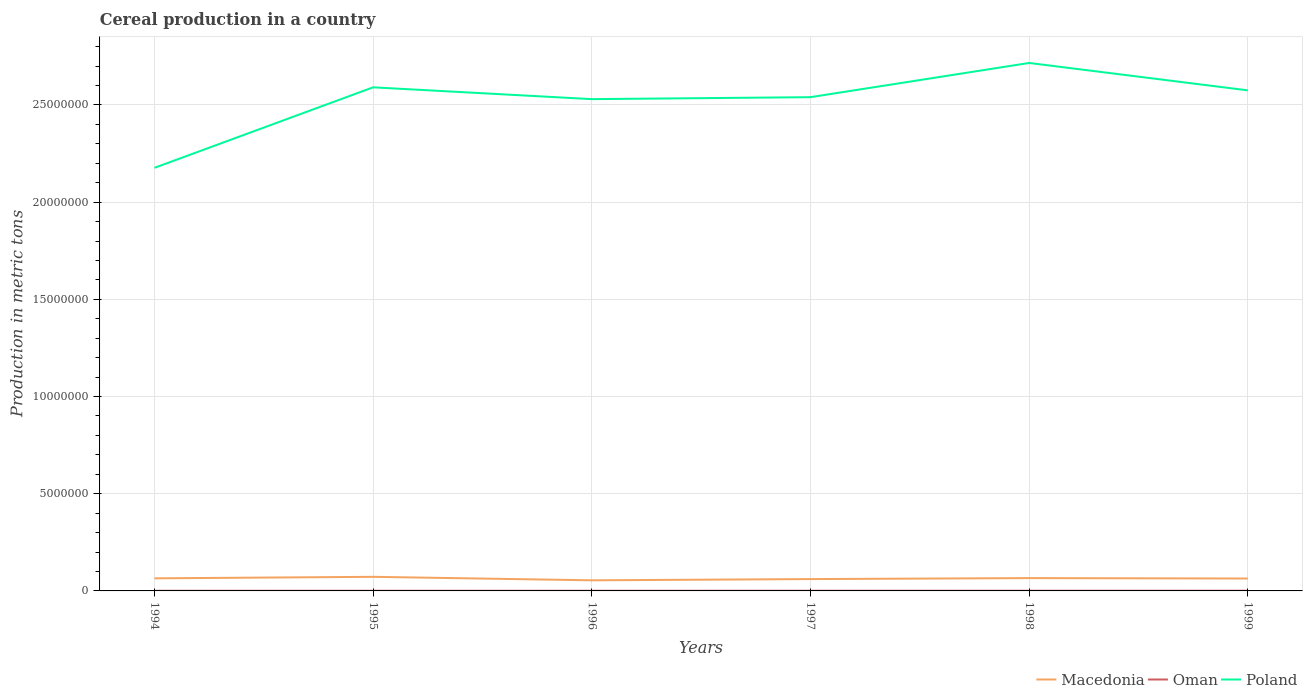How many different coloured lines are there?
Keep it short and to the point. 3. Across all years, what is the maximum total cereal production in Poland?
Make the answer very short. 2.18e+07. In which year was the total cereal production in Oman maximum?
Provide a succinct answer. 1994. What is the total total cereal production in Poland in the graph?
Make the answer very short. -3.99e+06. What is the difference between the highest and the second highest total cereal production in Macedonia?
Provide a short and direct response. 1.79e+05. How many years are there in the graph?
Your response must be concise. 6. Are the values on the major ticks of Y-axis written in scientific E-notation?
Ensure brevity in your answer.  No. Does the graph contain any zero values?
Offer a terse response. No. Does the graph contain grids?
Make the answer very short. Yes. How many legend labels are there?
Provide a short and direct response. 3. What is the title of the graph?
Your answer should be very brief. Cereal production in a country. What is the label or title of the Y-axis?
Your answer should be compact. Production in metric tons. What is the Production in metric tons in Macedonia in 1994?
Your answer should be compact. 6.48e+05. What is the Production in metric tons in Oman in 1994?
Offer a terse response. 7145. What is the Production in metric tons of Poland in 1994?
Provide a succinct answer. 2.18e+07. What is the Production in metric tons of Macedonia in 1995?
Keep it short and to the point. 7.25e+05. What is the Production in metric tons of Oman in 1995?
Your response must be concise. 8000. What is the Production in metric tons of Poland in 1995?
Offer a very short reply. 2.59e+07. What is the Production in metric tons of Macedonia in 1996?
Ensure brevity in your answer.  5.46e+05. What is the Production in metric tons in Oman in 1996?
Ensure brevity in your answer.  8760. What is the Production in metric tons of Poland in 1996?
Your answer should be compact. 2.53e+07. What is the Production in metric tons in Macedonia in 1997?
Ensure brevity in your answer.  6.10e+05. What is the Production in metric tons in Oman in 1997?
Your answer should be compact. 9450. What is the Production in metric tons in Poland in 1997?
Offer a terse response. 2.54e+07. What is the Production in metric tons of Macedonia in 1998?
Provide a short and direct response. 6.60e+05. What is the Production in metric tons of Oman in 1998?
Give a very brief answer. 9697. What is the Production in metric tons of Poland in 1998?
Make the answer very short. 2.72e+07. What is the Production in metric tons of Macedonia in 1999?
Provide a short and direct response. 6.38e+05. What is the Production in metric tons of Oman in 1999?
Offer a terse response. 1.07e+04. What is the Production in metric tons of Poland in 1999?
Keep it short and to the point. 2.58e+07. Across all years, what is the maximum Production in metric tons in Macedonia?
Ensure brevity in your answer.  7.25e+05. Across all years, what is the maximum Production in metric tons in Oman?
Your answer should be very brief. 1.07e+04. Across all years, what is the maximum Production in metric tons in Poland?
Give a very brief answer. 2.72e+07. Across all years, what is the minimum Production in metric tons of Macedonia?
Your response must be concise. 5.46e+05. Across all years, what is the minimum Production in metric tons in Oman?
Offer a terse response. 7145. Across all years, what is the minimum Production in metric tons of Poland?
Provide a succinct answer. 2.18e+07. What is the total Production in metric tons in Macedonia in the graph?
Your answer should be compact. 3.83e+06. What is the total Production in metric tons in Oman in the graph?
Ensure brevity in your answer.  5.37e+04. What is the total Production in metric tons of Poland in the graph?
Offer a terse response. 1.51e+08. What is the difference between the Production in metric tons of Macedonia in 1994 and that in 1995?
Provide a short and direct response. -7.72e+04. What is the difference between the Production in metric tons of Oman in 1994 and that in 1995?
Provide a short and direct response. -855. What is the difference between the Production in metric tons in Poland in 1994 and that in 1995?
Your response must be concise. -4.14e+06. What is the difference between the Production in metric tons of Macedonia in 1994 and that in 1996?
Offer a very short reply. 1.02e+05. What is the difference between the Production in metric tons in Oman in 1994 and that in 1996?
Make the answer very short. -1615. What is the difference between the Production in metric tons in Poland in 1994 and that in 1996?
Provide a short and direct response. -3.53e+06. What is the difference between the Production in metric tons of Macedonia in 1994 and that in 1997?
Keep it short and to the point. 3.81e+04. What is the difference between the Production in metric tons in Oman in 1994 and that in 1997?
Offer a very short reply. -2305. What is the difference between the Production in metric tons in Poland in 1994 and that in 1997?
Offer a terse response. -3.64e+06. What is the difference between the Production in metric tons in Macedonia in 1994 and that in 1998?
Keep it short and to the point. -1.21e+04. What is the difference between the Production in metric tons in Oman in 1994 and that in 1998?
Give a very brief answer. -2552. What is the difference between the Production in metric tons of Poland in 1994 and that in 1998?
Offer a very short reply. -5.40e+06. What is the difference between the Production in metric tons in Macedonia in 1994 and that in 1999?
Keep it short and to the point. 9877. What is the difference between the Production in metric tons of Oman in 1994 and that in 1999?
Your answer should be compact. -3540. What is the difference between the Production in metric tons in Poland in 1994 and that in 1999?
Provide a succinct answer. -3.99e+06. What is the difference between the Production in metric tons of Macedonia in 1995 and that in 1996?
Give a very brief answer. 1.79e+05. What is the difference between the Production in metric tons of Oman in 1995 and that in 1996?
Keep it short and to the point. -760. What is the difference between the Production in metric tons of Poland in 1995 and that in 1996?
Your answer should be compact. 6.07e+05. What is the difference between the Production in metric tons in Macedonia in 1995 and that in 1997?
Provide a short and direct response. 1.15e+05. What is the difference between the Production in metric tons in Oman in 1995 and that in 1997?
Your answer should be very brief. -1450. What is the difference between the Production in metric tons in Poland in 1995 and that in 1997?
Offer a terse response. 5.06e+05. What is the difference between the Production in metric tons in Macedonia in 1995 and that in 1998?
Provide a short and direct response. 6.51e+04. What is the difference between the Production in metric tons of Oman in 1995 and that in 1998?
Provide a short and direct response. -1697. What is the difference between the Production in metric tons in Poland in 1995 and that in 1998?
Offer a terse response. -1.25e+06. What is the difference between the Production in metric tons in Macedonia in 1995 and that in 1999?
Offer a very short reply. 8.71e+04. What is the difference between the Production in metric tons in Oman in 1995 and that in 1999?
Keep it short and to the point. -2685. What is the difference between the Production in metric tons in Poland in 1995 and that in 1999?
Your answer should be very brief. 1.55e+05. What is the difference between the Production in metric tons in Macedonia in 1996 and that in 1997?
Make the answer very short. -6.40e+04. What is the difference between the Production in metric tons of Oman in 1996 and that in 1997?
Make the answer very short. -690. What is the difference between the Production in metric tons of Poland in 1996 and that in 1997?
Provide a succinct answer. -1.02e+05. What is the difference between the Production in metric tons in Macedonia in 1996 and that in 1998?
Offer a very short reply. -1.14e+05. What is the difference between the Production in metric tons of Oman in 1996 and that in 1998?
Offer a very short reply. -937. What is the difference between the Production in metric tons of Poland in 1996 and that in 1998?
Ensure brevity in your answer.  -1.86e+06. What is the difference between the Production in metric tons in Macedonia in 1996 and that in 1999?
Provide a short and direct response. -9.22e+04. What is the difference between the Production in metric tons of Oman in 1996 and that in 1999?
Offer a terse response. -1925. What is the difference between the Production in metric tons of Poland in 1996 and that in 1999?
Your response must be concise. -4.52e+05. What is the difference between the Production in metric tons of Macedonia in 1997 and that in 1998?
Make the answer very short. -5.02e+04. What is the difference between the Production in metric tons of Oman in 1997 and that in 1998?
Offer a terse response. -247. What is the difference between the Production in metric tons of Poland in 1997 and that in 1998?
Offer a very short reply. -1.76e+06. What is the difference between the Production in metric tons in Macedonia in 1997 and that in 1999?
Offer a terse response. -2.82e+04. What is the difference between the Production in metric tons in Oman in 1997 and that in 1999?
Your answer should be compact. -1235. What is the difference between the Production in metric tons in Poland in 1997 and that in 1999?
Provide a short and direct response. -3.51e+05. What is the difference between the Production in metric tons of Macedonia in 1998 and that in 1999?
Keep it short and to the point. 2.20e+04. What is the difference between the Production in metric tons of Oman in 1998 and that in 1999?
Your response must be concise. -988. What is the difference between the Production in metric tons of Poland in 1998 and that in 1999?
Keep it short and to the point. 1.41e+06. What is the difference between the Production in metric tons of Macedonia in 1994 and the Production in metric tons of Oman in 1995?
Offer a terse response. 6.40e+05. What is the difference between the Production in metric tons of Macedonia in 1994 and the Production in metric tons of Poland in 1995?
Keep it short and to the point. -2.53e+07. What is the difference between the Production in metric tons in Oman in 1994 and the Production in metric tons in Poland in 1995?
Give a very brief answer. -2.59e+07. What is the difference between the Production in metric tons of Macedonia in 1994 and the Production in metric tons of Oman in 1996?
Ensure brevity in your answer.  6.39e+05. What is the difference between the Production in metric tons of Macedonia in 1994 and the Production in metric tons of Poland in 1996?
Keep it short and to the point. -2.47e+07. What is the difference between the Production in metric tons of Oman in 1994 and the Production in metric tons of Poland in 1996?
Your response must be concise. -2.53e+07. What is the difference between the Production in metric tons of Macedonia in 1994 and the Production in metric tons of Oman in 1997?
Offer a terse response. 6.38e+05. What is the difference between the Production in metric tons in Macedonia in 1994 and the Production in metric tons in Poland in 1997?
Provide a short and direct response. -2.48e+07. What is the difference between the Production in metric tons of Oman in 1994 and the Production in metric tons of Poland in 1997?
Ensure brevity in your answer.  -2.54e+07. What is the difference between the Production in metric tons of Macedonia in 1994 and the Production in metric tons of Oman in 1998?
Your answer should be very brief. 6.38e+05. What is the difference between the Production in metric tons in Macedonia in 1994 and the Production in metric tons in Poland in 1998?
Give a very brief answer. -2.65e+07. What is the difference between the Production in metric tons of Oman in 1994 and the Production in metric tons of Poland in 1998?
Give a very brief answer. -2.72e+07. What is the difference between the Production in metric tons of Macedonia in 1994 and the Production in metric tons of Oman in 1999?
Make the answer very short. 6.37e+05. What is the difference between the Production in metric tons in Macedonia in 1994 and the Production in metric tons in Poland in 1999?
Make the answer very short. -2.51e+07. What is the difference between the Production in metric tons of Oman in 1994 and the Production in metric tons of Poland in 1999?
Ensure brevity in your answer.  -2.57e+07. What is the difference between the Production in metric tons in Macedonia in 1995 and the Production in metric tons in Oman in 1996?
Offer a terse response. 7.16e+05. What is the difference between the Production in metric tons of Macedonia in 1995 and the Production in metric tons of Poland in 1996?
Your response must be concise. -2.46e+07. What is the difference between the Production in metric tons in Oman in 1995 and the Production in metric tons in Poland in 1996?
Provide a succinct answer. -2.53e+07. What is the difference between the Production in metric tons in Macedonia in 1995 and the Production in metric tons in Oman in 1997?
Offer a very short reply. 7.15e+05. What is the difference between the Production in metric tons of Macedonia in 1995 and the Production in metric tons of Poland in 1997?
Provide a succinct answer. -2.47e+07. What is the difference between the Production in metric tons of Oman in 1995 and the Production in metric tons of Poland in 1997?
Make the answer very short. -2.54e+07. What is the difference between the Production in metric tons of Macedonia in 1995 and the Production in metric tons of Oman in 1998?
Your answer should be compact. 7.15e+05. What is the difference between the Production in metric tons in Macedonia in 1995 and the Production in metric tons in Poland in 1998?
Keep it short and to the point. -2.64e+07. What is the difference between the Production in metric tons of Oman in 1995 and the Production in metric tons of Poland in 1998?
Offer a terse response. -2.72e+07. What is the difference between the Production in metric tons in Macedonia in 1995 and the Production in metric tons in Oman in 1999?
Keep it short and to the point. 7.14e+05. What is the difference between the Production in metric tons of Macedonia in 1995 and the Production in metric tons of Poland in 1999?
Your answer should be compact. -2.50e+07. What is the difference between the Production in metric tons of Oman in 1995 and the Production in metric tons of Poland in 1999?
Provide a short and direct response. -2.57e+07. What is the difference between the Production in metric tons of Macedonia in 1996 and the Production in metric tons of Oman in 1997?
Provide a succinct answer. 5.36e+05. What is the difference between the Production in metric tons in Macedonia in 1996 and the Production in metric tons in Poland in 1997?
Provide a short and direct response. -2.49e+07. What is the difference between the Production in metric tons in Oman in 1996 and the Production in metric tons in Poland in 1997?
Provide a short and direct response. -2.54e+07. What is the difference between the Production in metric tons of Macedonia in 1996 and the Production in metric tons of Oman in 1998?
Offer a very short reply. 5.36e+05. What is the difference between the Production in metric tons of Macedonia in 1996 and the Production in metric tons of Poland in 1998?
Offer a terse response. -2.66e+07. What is the difference between the Production in metric tons of Oman in 1996 and the Production in metric tons of Poland in 1998?
Provide a succinct answer. -2.71e+07. What is the difference between the Production in metric tons in Macedonia in 1996 and the Production in metric tons in Oman in 1999?
Provide a succinct answer. 5.35e+05. What is the difference between the Production in metric tons of Macedonia in 1996 and the Production in metric tons of Poland in 1999?
Your answer should be compact. -2.52e+07. What is the difference between the Production in metric tons in Oman in 1996 and the Production in metric tons in Poland in 1999?
Offer a very short reply. -2.57e+07. What is the difference between the Production in metric tons of Macedonia in 1997 and the Production in metric tons of Oman in 1998?
Offer a terse response. 6.00e+05. What is the difference between the Production in metric tons of Macedonia in 1997 and the Production in metric tons of Poland in 1998?
Your answer should be compact. -2.65e+07. What is the difference between the Production in metric tons in Oman in 1997 and the Production in metric tons in Poland in 1998?
Make the answer very short. -2.71e+07. What is the difference between the Production in metric tons in Macedonia in 1997 and the Production in metric tons in Oman in 1999?
Give a very brief answer. 5.99e+05. What is the difference between the Production in metric tons of Macedonia in 1997 and the Production in metric tons of Poland in 1999?
Offer a terse response. -2.51e+07. What is the difference between the Production in metric tons of Oman in 1997 and the Production in metric tons of Poland in 1999?
Provide a succinct answer. -2.57e+07. What is the difference between the Production in metric tons in Macedonia in 1998 and the Production in metric tons in Oman in 1999?
Offer a terse response. 6.49e+05. What is the difference between the Production in metric tons of Macedonia in 1998 and the Production in metric tons of Poland in 1999?
Offer a very short reply. -2.51e+07. What is the difference between the Production in metric tons of Oman in 1998 and the Production in metric tons of Poland in 1999?
Your answer should be very brief. -2.57e+07. What is the average Production in metric tons of Macedonia per year?
Your response must be concise. 6.38e+05. What is the average Production in metric tons of Oman per year?
Provide a succinct answer. 8956.17. What is the average Production in metric tons of Poland per year?
Offer a terse response. 2.52e+07. In the year 1994, what is the difference between the Production in metric tons in Macedonia and Production in metric tons in Oman?
Offer a very short reply. 6.41e+05. In the year 1994, what is the difference between the Production in metric tons in Macedonia and Production in metric tons in Poland?
Offer a terse response. -2.11e+07. In the year 1994, what is the difference between the Production in metric tons of Oman and Production in metric tons of Poland?
Provide a succinct answer. -2.18e+07. In the year 1995, what is the difference between the Production in metric tons of Macedonia and Production in metric tons of Oman?
Your answer should be very brief. 7.17e+05. In the year 1995, what is the difference between the Production in metric tons in Macedonia and Production in metric tons in Poland?
Ensure brevity in your answer.  -2.52e+07. In the year 1995, what is the difference between the Production in metric tons in Oman and Production in metric tons in Poland?
Your answer should be very brief. -2.59e+07. In the year 1996, what is the difference between the Production in metric tons of Macedonia and Production in metric tons of Oman?
Your answer should be very brief. 5.37e+05. In the year 1996, what is the difference between the Production in metric tons of Macedonia and Production in metric tons of Poland?
Provide a succinct answer. -2.48e+07. In the year 1996, what is the difference between the Production in metric tons in Oman and Production in metric tons in Poland?
Your answer should be very brief. -2.53e+07. In the year 1997, what is the difference between the Production in metric tons of Macedonia and Production in metric tons of Oman?
Ensure brevity in your answer.  6.00e+05. In the year 1997, what is the difference between the Production in metric tons of Macedonia and Production in metric tons of Poland?
Keep it short and to the point. -2.48e+07. In the year 1997, what is the difference between the Production in metric tons in Oman and Production in metric tons in Poland?
Ensure brevity in your answer.  -2.54e+07. In the year 1998, what is the difference between the Production in metric tons of Macedonia and Production in metric tons of Oman?
Provide a short and direct response. 6.50e+05. In the year 1998, what is the difference between the Production in metric tons in Macedonia and Production in metric tons in Poland?
Your answer should be compact. -2.65e+07. In the year 1998, what is the difference between the Production in metric tons of Oman and Production in metric tons of Poland?
Provide a short and direct response. -2.71e+07. In the year 1999, what is the difference between the Production in metric tons in Macedonia and Production in metric tons in Oman?
Provide a succinct answer. 6.27e+05. In the year 1999, what is the difference between the Production in metric tons of Macedonia and Production in metric tons of Poland?
Your answer should be compact. -2.51e+07. In the year 1999, what is the difference between the Production in metric tons in Oman and Production in metric tons in Poland?
Ensure brevity in your answer.  -2.57e+07. What is the ratio of the Production in metric tons in Macedonia in 1994 to that in 1995?
Your answer should be compact. 0.89. What is the ratio of the Production in metric tons of Oman in 1994 to that in 1995?
Ensure brevity in your answer.  0.89. What is the ratio of the Production in metric tons of Poland in 1994 to that in 1995?
Make the answer very short. 0.84. What is the ratio of the Production in metric tons of Macedonia in 1994 to that in 1996?
Provide a short and direct response. 1.19. What is the ratio of the Production in metric tons of Oman in 1994 to that in 1996?
Provide a succinct answer. 0.82. What is the ratio of the Production in metric tons in Poland in 1994 to that in 1996?
Give a very brief answer. 0.86. What is the ratio of the Production in metric tons in Oman in 1994 to that in 1997?
Offer a very short reply. 0.76. What is the ratio of the Production in metric tons of Poland in 1994 to that in 1997?
Keep it short and to the point. 0.86. What is the ratio of the Production in metric tons of Macedonia in 1994 to that in 1998?
Your answer should be compact. 0.98. What is the ratio of the Production in metric tons of Oman in 1994 to that in 1998?
Ensure brevity in your answer.  0.74. What is the ratio of the Production in metric tons of Poland in 1994 to that in 1998?
Provide a succinct answer. 0.8. What is the ratio of the Production in metric tons of Macedonia in 1994 to that in 1999?
Provide a succinct answer. 1.02. What is the ratio of the Production in metric tons in Oman in 1994 to that in 1999?
Provide a succinct answer. 0.67. What is the ratio of the Production in metric tons of Poland in 1994 to that in 1999?
Offer a very short reply. 0.85. What is the ratio of the Production in metric tons in Macedonia in 1995 to that in 1996?
Give a very brief answer. 1.33. What is the ratio of the Production in metric tons of Oman in 1995 to that in 1996?
Your answer should be very brief. 0.91. What is the ratio of the Production in metric tons of Poland in 1995 to that in 1996?
Provide a short and direct response. 1.02. What is the ratio of the Production in metric tons of Macedonia in 1995 to that in 1997?
Give a very brief answer. 1.19. What is the ratio of the Production in metric tons in Oman in 1995 to that in 1997?
Your answer should be compact. 0.85. What is the ratio of the Production in metric tons of Poland in 1995 to that in 1997?
Offer a very short reply. 1.02. What is the ratio of the Production in metric tons in Macedonia in 1995 to that in 1998?
Ensure brevity in your answer.  1.1. What is the ratio of the Production in metric tons of Oman in 1995 to that in 1998?
Ensure brevity in your answer.  0.82. What is the ratio of the Production in metric tons in Poland in 1995 to that in 1998?
Give a very brief answer. 0.95. What is the ratio of the Production in metric tons in Macedonia in 1995 to that in 1999?
Offer a terse response. 1.14. What is the ratio of the Production in metric tons of Oman in 1995 to that in 1999?
Ensure brevity in your answer.  0.75. What is the ratio of the Production in metric tons in Poland in 1995 to that in 1999?
Your answer should be very brief. 1.01. What is the ratio of the Production in metric tons of Macedonia in 1996 to that in 1997?
Offer a very short reply. 0.9. What is the ratio of the Production in metric tons in Oman in 1996 to that in 1997?
Offer a terse response. 0.93. What is the ratio of the Production in metric tons of Poland in 1996 to that in 1997?
Provide a succinct answer. 1. What is the ratio of the Production in metric tons of Macedonia in 1996 to that in 1998?
Give a very brief answer. 0.83. What is the ratio of the Production in metric tons of Oman in 1996 to that in 1998?
Your response must be concise. 0.9. What is the ratio of the Production in metric tons of Poland in 1996 to that in 1998?
Offer a terse response. 0.93. What is the ratio of the Production in metric tons in Macedonia in 1996 to that in 1999?
Provide a short and direct response. 0.86. What is the ratio of the Production in metric tons of Oman in 1996 to that in 1999?
Your answer should be compact. 0.82. What is the ratio of the Production in metric tons of Poland in 1996 to that in 1999?
Offer a terse response. 0.98. What is the ratio of the Production in metric tons of Macedonia in 1997 to that in 1998?
Provide a short and direct response. 0.92. What is the ratio of the Production in metric tons of Oman in 1997 to that in 1998?
Offer a terse response. 0.97. What is the ratio of the Production in metric tons in Poland in 1997 to that in 1998?
Provide a succinct answer. 0.94. What is the ratio of the Production in metric tons in Macedonia in 1997 to that in 1999?
Ensure brevity in your answer.  0.96. What is the ratio of the Production in metric tons in Oman in 1997 to that in 1999?
Offer a terse response. 0.88. What is the ratio of the Production in metric tons in Poland in 1997 to that in 1999?
Give a very brief answer. 0.99. What is the ratio of the Production in metric tons in Macedonia in 1998 to that in 1999?
Offer a very short reply. 1.03. What is the ratio of the Production in metric tons of Oman in 1998 to that in 1999?
Your answer should be very brief. 0.91. What is the ratio of the Production in metric tons of Poland in 1998 to that in 1999?
Give a very brief answer. 1.05. What is the difference between the highest and the second highest Production in metric tons of Macedonia?
Offer a very short reply. 6.51e+04. What is the difference between the highest and the second highest Production in metric tons in Oman?
Offer a terse response. 988. What is the difference between the highest and the second highest Production in metric tons of Poland?
Provide a succinct answer. 1.25e+06. What is the difference between the highest and the lowest Production in metric tons in Macedonia?
Your response must be concise. 1.79e+05. What is the difference between the highest and the lowest Production in metric tons in Oman?
Your answer should be compact. 3540. What is the difference between the highest and the lowest Production in metric tons in Poland?
Offer a terse response. 5.40e+06. 